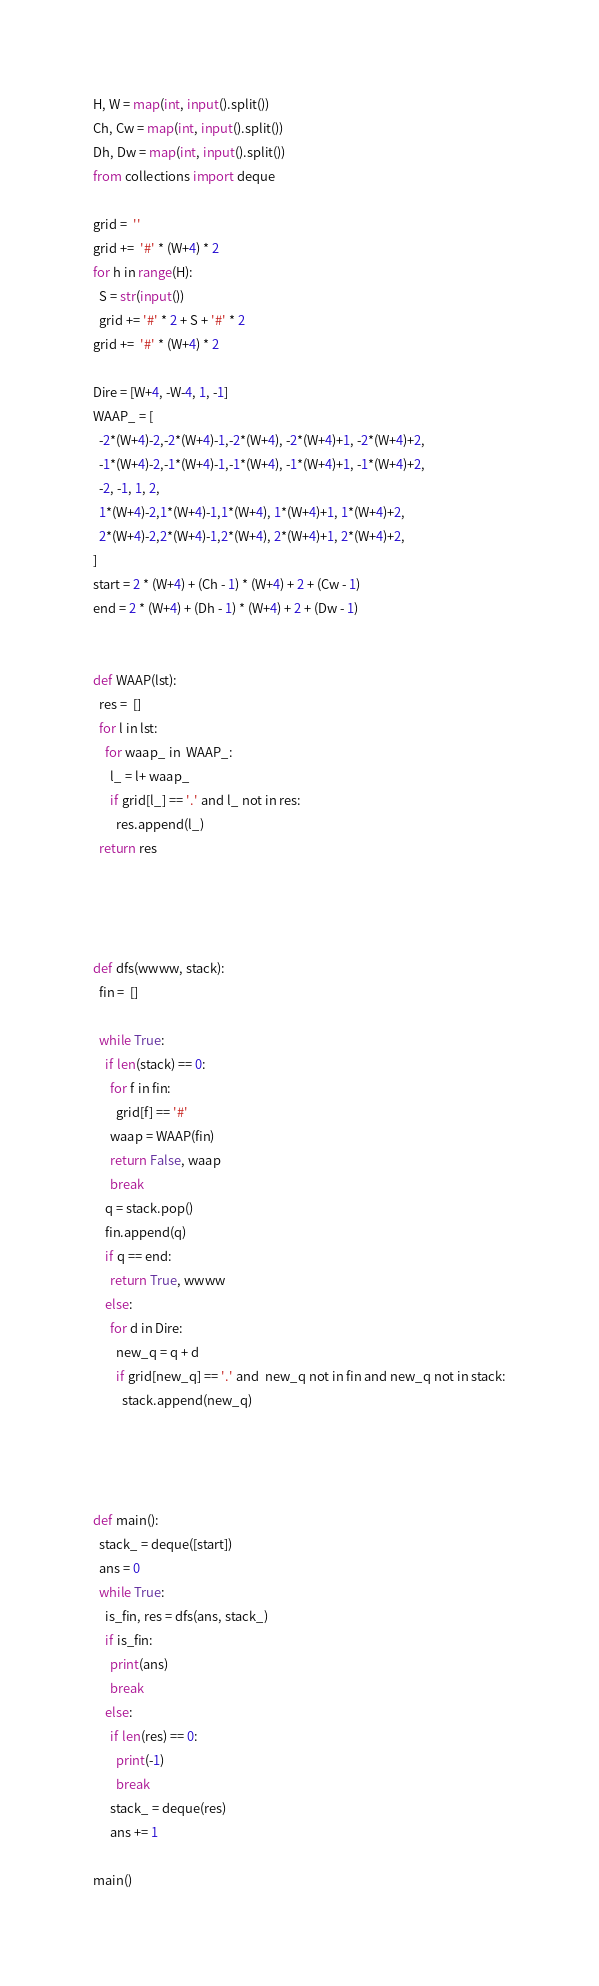<code> <loc_0><loc_0><loc_500><loc_500><_Cython_>H, W = map(int, input().split())
Ch, Cw = map(int, input().split())
Dh, Dw = map(int, input().split())
from collections import deque

grid =  ''
grid +=  '#' * (W+4) * 2
for h in range(H):
  S = str(input())
  grid += '#' * 2 + S + '#' * 2
grid +=  '#' * (W+4) * 2

Dire = [W+4, -W-4, 1, -1]
WAAP_ = [
  -2*(W+4)-2,-2*(W+4)-1,-2*(W+4), -2*(W+4)+1, -2*(W+4)+2, 
  -1*(W+4)-2,-1*(W+4)-1,-1*(W+4), -1*(W+4)+1, -1*(W+4)+2, 
  -2, -1, 1, 2,
  1*(W+4)-2,1*(W+4)-1,1*(W+4), 1*(W+4)+1, 1*(W+4)+2, 
  2*(W+4)-2,2*(W+4)-1,2*(W+4), 2*(W+4)+1, 2*(W+4)+2, 
]
start = 2 * (W+4) + (Ch - 1) * (W+4) + 2 + (Cw - 1)
end = 2 * (W+4) + (Dh - 1) * (W+4) + 2 + (Dw - 1)


def WAAP(lst):
  res =  []
  for l in lst:
    for waap_ in  WAAP_:
      l_ = l+ waap_
      if grid[l_] == '.' and l_ not in res:
        res.append(l_)
  return res
        
        
    

def dfs(wwww, stack):
  fin =  []
  
  while True:
    if len(stack) == 0:
      for f in fin:
        grid[f] == '#'
      waap = WAAP(fin)
      return False, waap
      break
    q = stack.pop()
    fin.append(q)
    if q == end:
      return True, wwww
    else:
      for d in Dire:
        new_q = q + d
        if grid[new_q] == '.' and  new_q not in fin and new_q not in stack:
          stack.append(new_q)
          
          
          
          
def main():
  stack_ = deque([start])
  ans = 0
  while True:
    is_fin, res = dfs(ans, stack_)
    if is_fin:
      print(ans)
      break
    else:
      if len(res) == 0:
        print(-1)
        break
      stack_ = deque(res)
      ans += 1
      
main()

</code> 